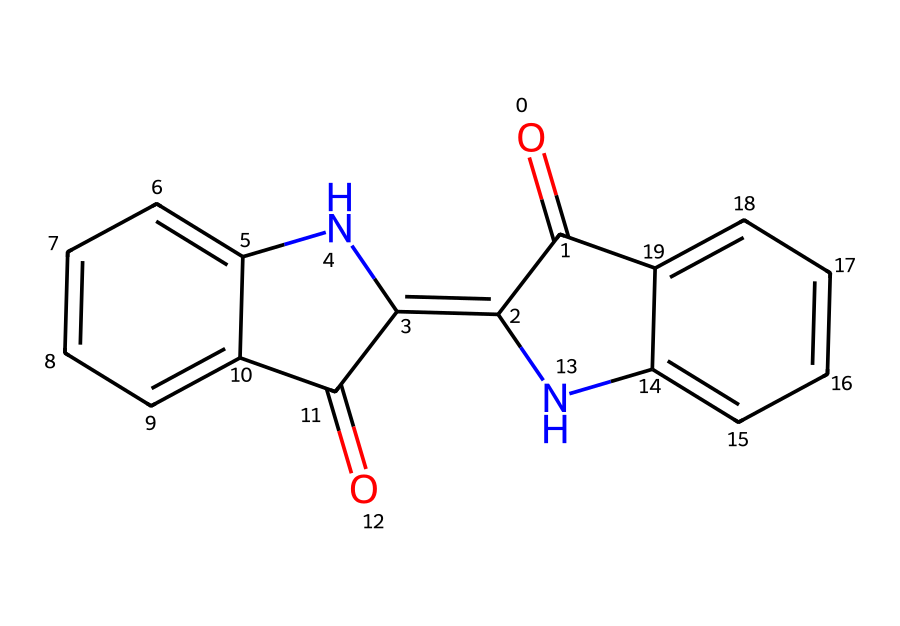What is the molecular formula of indigo dye? By examining the structure, we find that it includes 16 carbon atoms (C), 10 hydrogen atoms (H), 2 nitrogen atoms (N), and 2 oxygen atoms (O). Combining these gives the molecular formula C16H10N2O2.
Answer: C16H10N2O2 How many rings are present in the indigo dye structure? The molecular structure contains three distinct cyclic structures identified by the rings of carbon atoms with alternating double bonds. Counting these reveals that there are three rings in total.
Answer: 3 Which atoms are part of the functional groups in indigo dye? Observing the structure reveals that the two nitrogen (N) atoms and the two oxygen (O) atoms contribute to functional groups, specifically contributing to the amine and carbonyl functional groups present in the structure.
Answer: nitrogen and oxygen What type of compound is indigo dye considered? The structure shows that indigo dye comprises primarily carbon and hydrogen, with additional nitrogen and oxygen functionalities, indicating that it is classified as an organic compound.
Answer: organic compound Why is indigo dye valued in ancient civilizations? The strong color properties derived from its complex structure, which allows for solid dyes that adhere well to textiles, led to its high value in ancient dyeing practices and textiles, making it significant in various cultural contexts.
Answer: strong color properties How many double bonds are present in the indigo dye structure? By analyzing the chemical structure, we note the presence of several areas where carbon atoms have double bonds, specifically counting five distinct double bonds throughout the entire molecule.
Answer: 5 